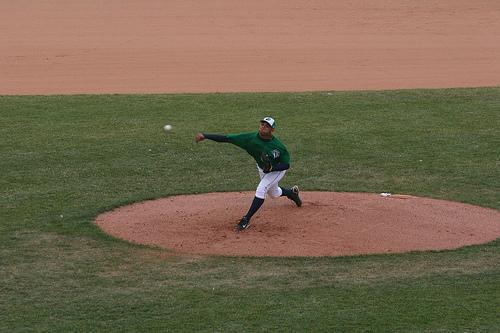How many players are in the photo?
Give a very brief answer. 1. 